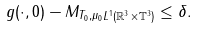Convert formula to latex. <formula><loc_0><loc_0><loc_500><loc_500>\| g ( \cdot , 0 ) - M _ { T _ { 0 } , \mu _ { 0 } } \| _ { L ^ { 1 } ( \mathbb { R } ^ { 3 } \times \mathbb { T } ^ { 3 } ) } \leq \delta .</formula> 